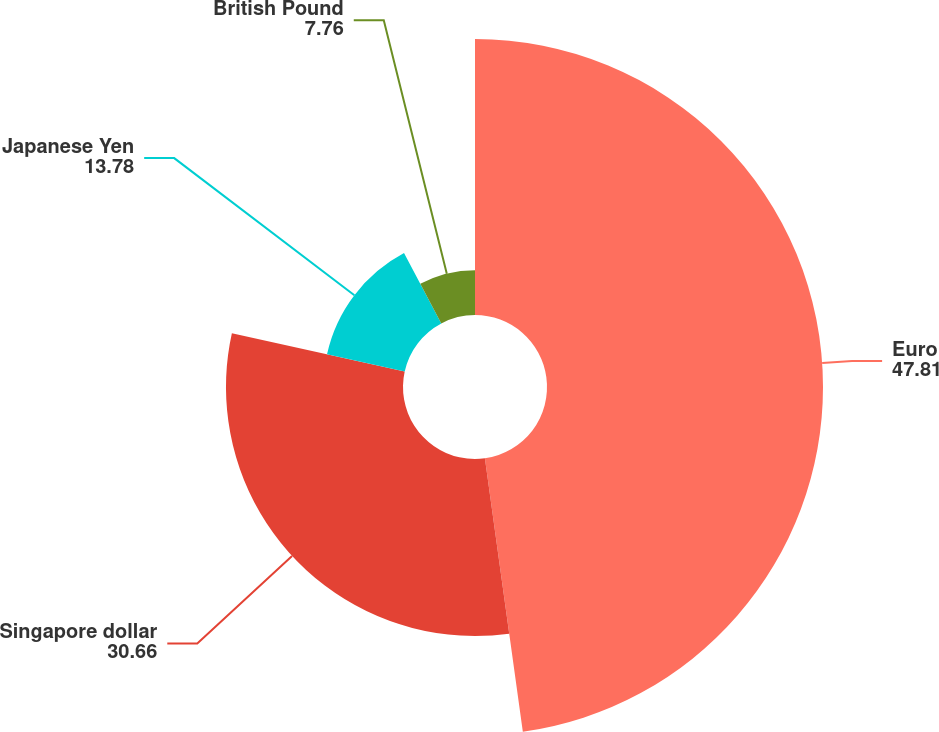Convert chart. <chart><loc_0><loc_0><loc_500><loc_500><pie_chart><fcel>Euro<fcel>Singapore dollar<fcel>Japanese Yen<fcel>British Pound<nl><fcel>47.81%<fcel>30.66%<fcel>13.78%<fcel>7.76%<nl></chart> 